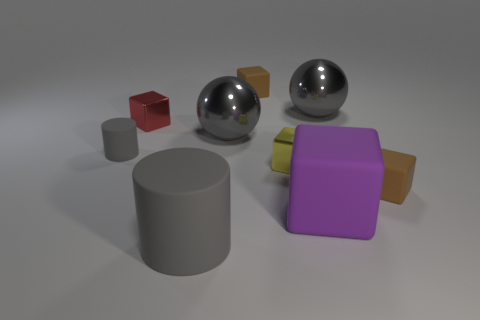Subtract all yellow cubes. How many cubes are left? 4 Subtract all yellow cubes. How many cubes are left? 4 Subtract all green cubes. Subtract all green cylinders. How many cubes are left? 5 Add 1 large brown shiny spheres. How many objects exist? 10 Subtract all blocks. How many objects are left? 4 Add 9 yellow cubes. How many yellow cubes are left? 10 Add 4 gray metal objects. How many gray metal objects exist? 6 Subtract 0 yellow spheres. How many objects are left? 9 Subtract all small yellow metal objects. Subtract all metallic objects. How many objects are left? 4 